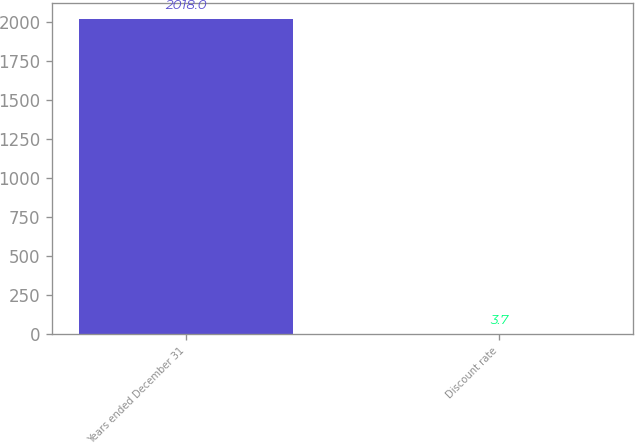Convert chart. <chart><loc_0><loc_0><loc_500><loc_500><bar_chart><fcel>Years ended December 31<fcel>Discount rate<nl><fcel>2018<fcel>3.7<nl></chart> 